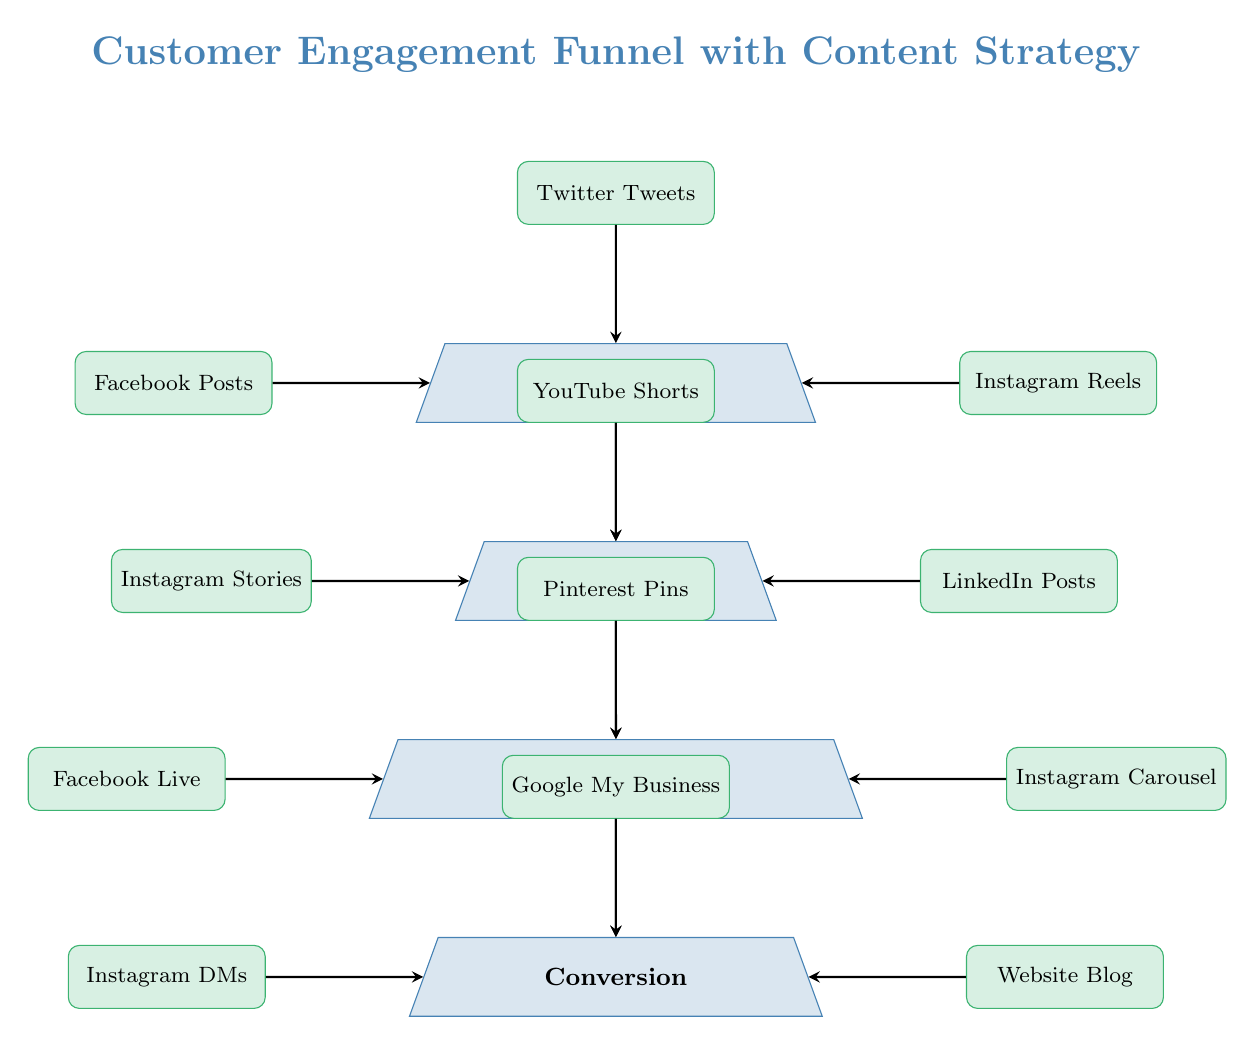What are the four stages of the customer engagement funnel? The diagram lists four stages vertically: Awareness, Interest, Consideration, and Conversion. These stages represent the progression of customer engagement in the funnel.
Answer: Awareness, Interest, Consideration, Conversion How many types of social media content lead to the Awareness stage? The diagram shows three types of content leading to the Awareness stage: Facebook Posts, Instagram Reels, and Twitter Tweets. This indicates there are three contributing content types for this stage.
Answer: Three Which type of social media content is associated with the Consideration stage? The diagram shows three content types contributing to the Consideration stage, which are Facebook Live, Instagram Carousel, and Pinterest Pins. These are intended to engage the audience further after generating interest.
Answer: Facebook Live, Instagram Carousel, Pinterest Pins What is the relationship between Interest and Conversion stages? The diagram illustrates a direct flow from the Interest stage to the Conversion stage, indicating that customer interest is intended to culminate in a conversion action.
Answer: Direct flow Which social media content type directly interacts with the Conversion stage? The Conversion stage is directly influenced by three content types: Instagram DMs, Website Blog, and Google My Business, which drive final customer actions leading to conversion.
Answer: Instagram DMs, Website Blog, Google My Business What is the primary purpose of the diagram? The diagram aims to show how different social media content types move customers through a funnel from awareness to conversion, effectively outlining a content strategy for local shops.
Answer: To illustrate customer engagement funnel What types of content create interest in the customer engagement funnel? The Interest stage includes three types of content: Instagram Stories, LinkedIn Posts, and YouTube Shorts. These are designed to engage the audience and push them deeper into the funnel.
Answer: Instagram Stories, LinkedIn Posts, YouTube Shorts How many connections (arrows) lead into the Conversion stage? The diagram displays three arrows leading into the Conversion stage, indicating the various content types that aim to finalize the engagement into a conversion.
Answer: Three Which social media platform has content leading to both the Awareness and Consideration stages? The platform Instagram has content contributing to both stages, with Instagram Reels for Awareness and Instagram Carousel for Consideration, showing its multifaceted role.
Answer: Instagram 